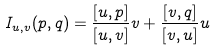Convert formula to latex. <formula><loc_0><loc_0><loc_500><loc_500>I _ { u , v } ( p , q ) = \frac { [ u , p ] } { [ u , v ] } v + \frac { [ v , q ] } { [ v , u ] } u</formula> 